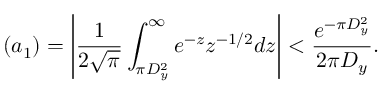<formula> <loc_0><loc_0><loc_500><loc_500>( a _ { 1 } ) = \left | { \frac { 1 } { 2 { \sqrt { \pi } } } } \int _ { \pi D _ { y } ^ { 2 } } ^ { \infty } e ^ { - z } z ^ { - 1 / 2 } d z \right | < { \frac { e ^ { - \pi D _ { y } ^ { 2 } } } { 2 \pi D _ { y } } } .</formula> 